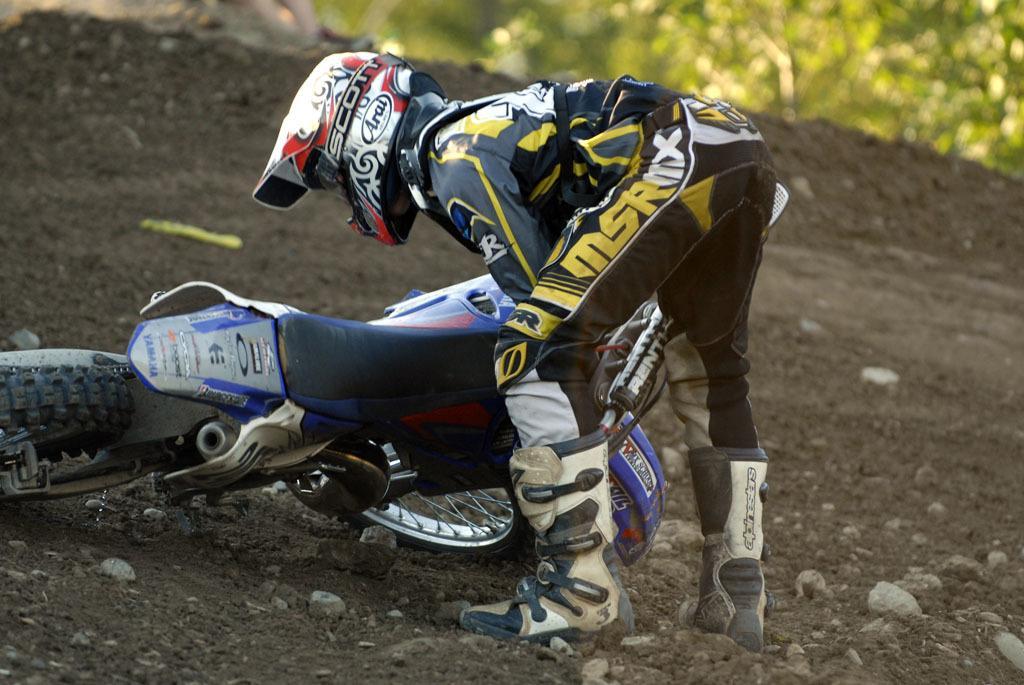In one or two sentences, can you explain what this image depicts? In this image there is a racer who is wearing the costume and a helmet is trying to lift the bike with his hands. At the bottom there is sand on which there are stones. In the background there are trees. 